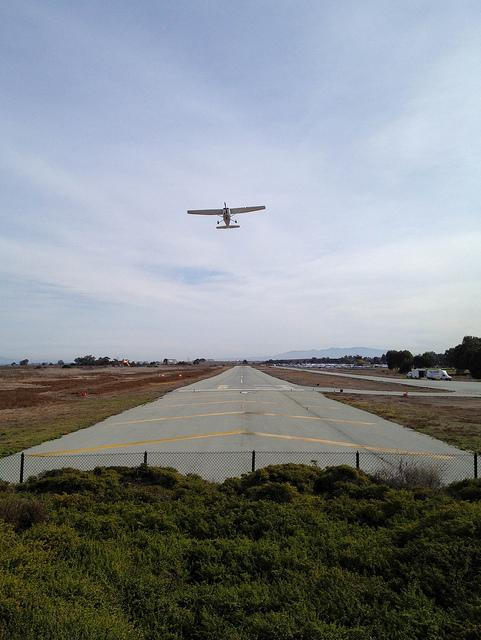What is the plane pictured above doing? Please explain your reasoning. take off. A plane is pointed up and is above a runway. 